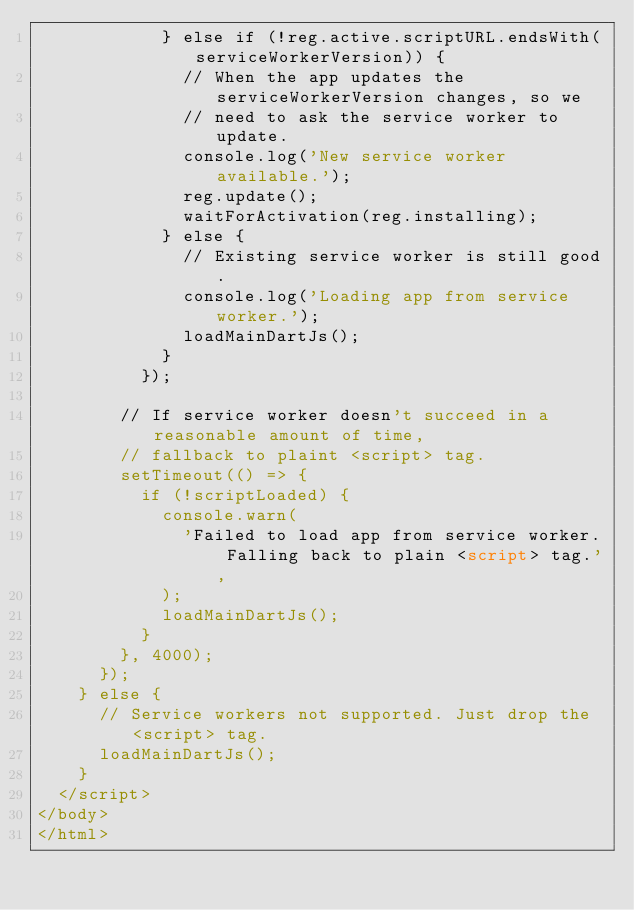<code> <loc_0><loc_0><loc_500><loc_500><_HTML_>            } else if (!reg.active.scriptURL.endsWith(serviceWorkerVersion)) {
              // When the app updates the serviceWorkerVersion changes, so we
              // need to ask the service worker to update.
              console.log('New service worker available.');
              reg.update();
              waitForActivation(reg.installing);
            } else {
              // Existing service worker is still good.
              console.log('Loading app from service worker.');
              loadMainDartJs();
            }
          });

        // If service worker doesn't succeed in a reasonable amount of time,
        // fallback to plaint <script> tag.
        setTimeout(() => {
          if (!scriptLoaded) {
            console.warn(
              'Failed to load app from service worker. Falling back to plain <script> tag.',
            );
            loadMainDartJs();
          }
        }, 4000);
      });
    } else {
      // Service workers not supported. Just drop the <script> tag.
      loadMainDartJs();
    }
  </script>
</body>
</html>
</code> 